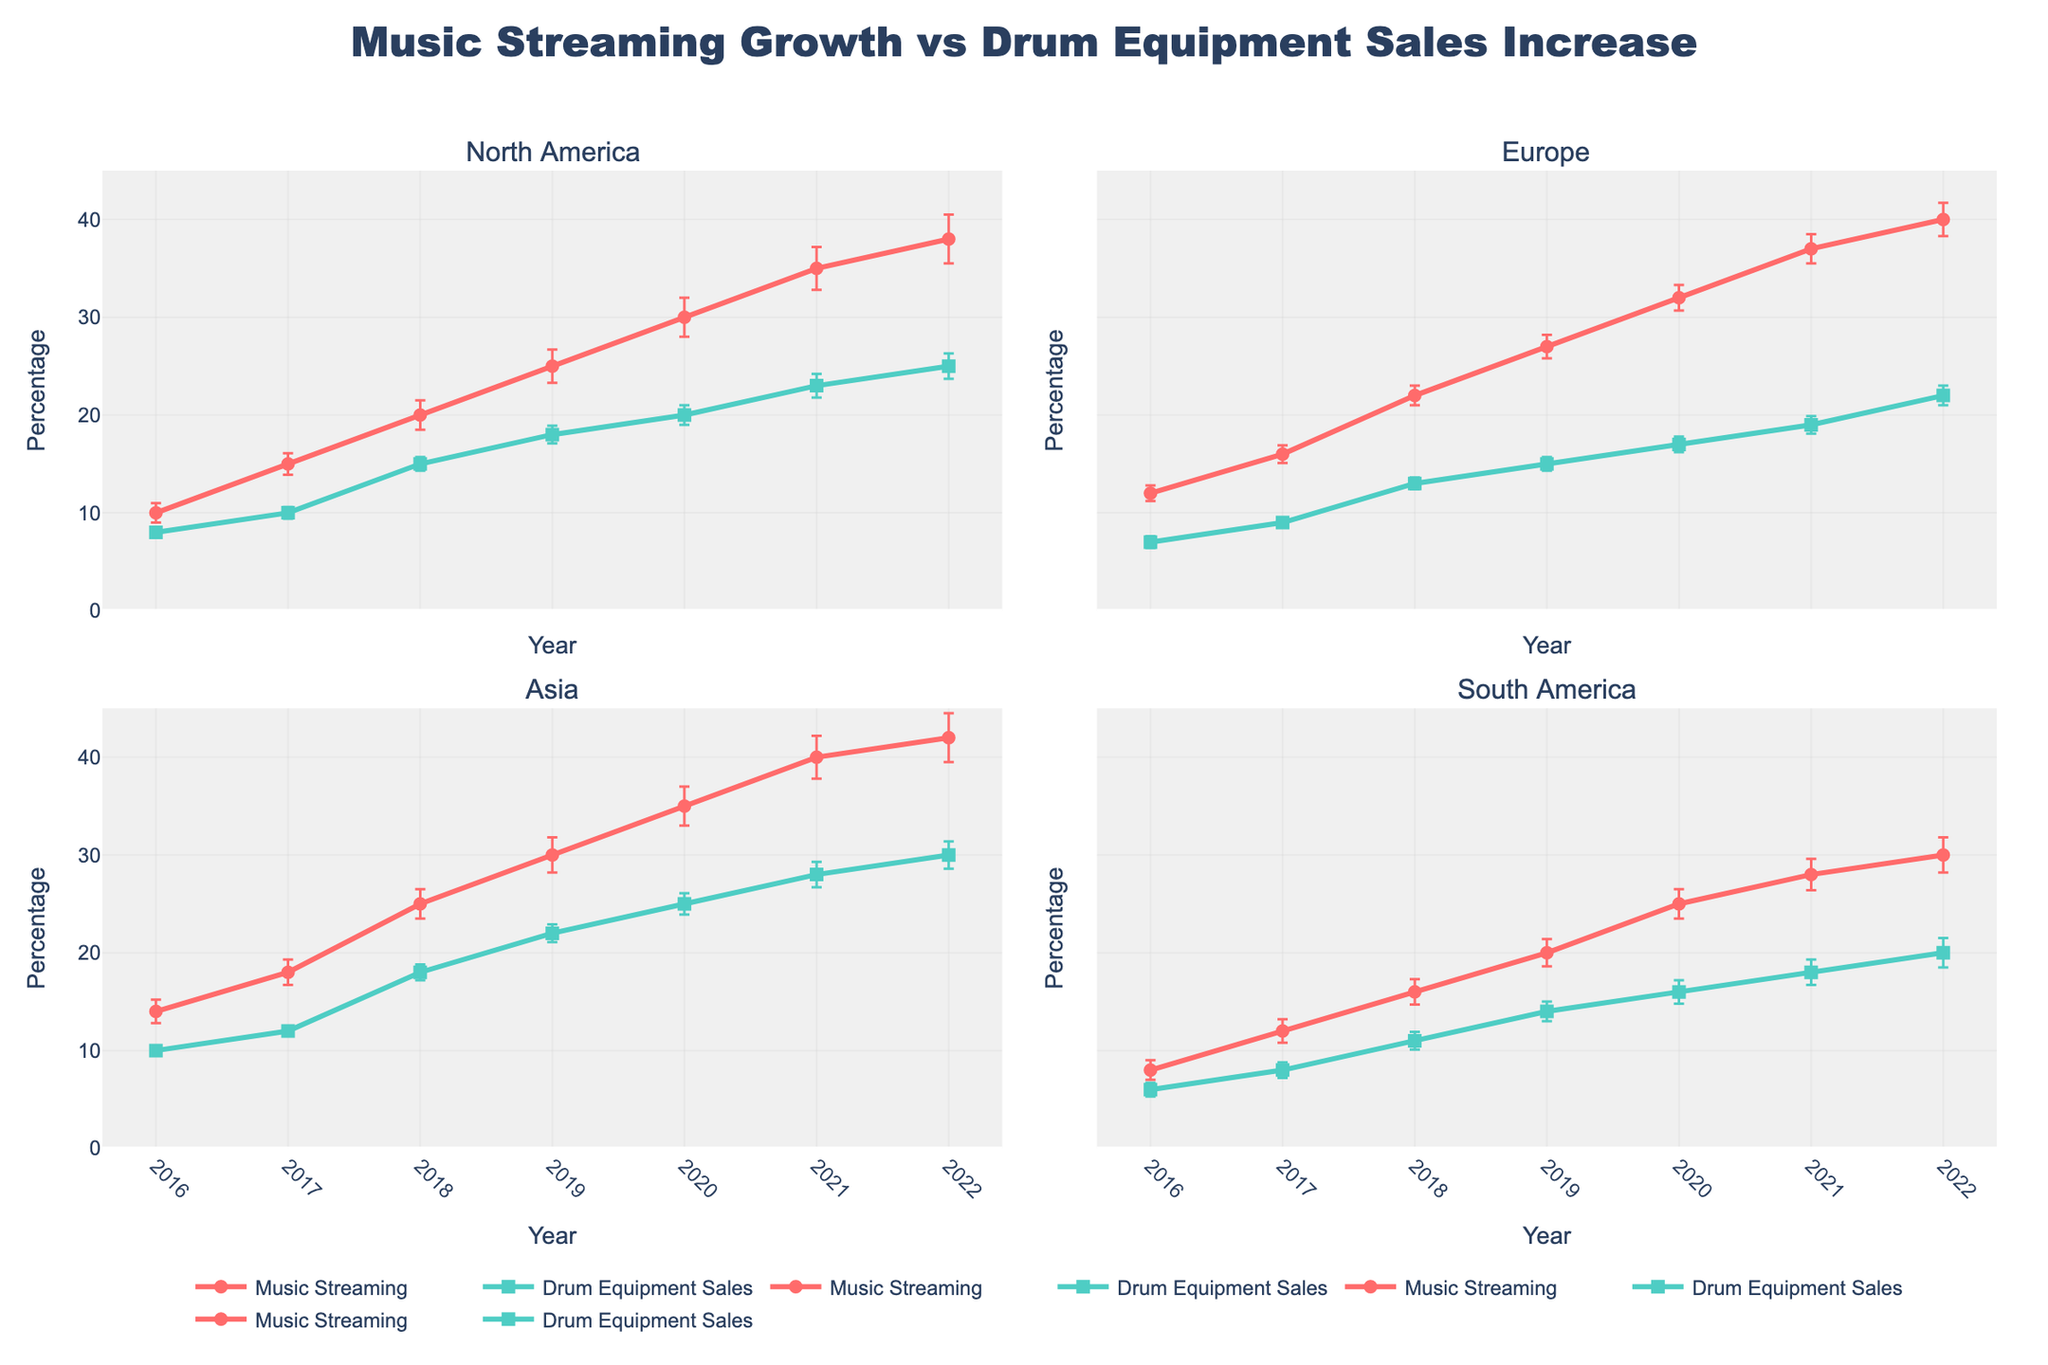How does the growth of music streaming subscribers in North America change from 2016 to 2022? In the plot for North America, look at the trend line for 'Music Streaming Subscribers Growth Percentage.' The line steadily increases each year from 2016 to 2022.
Answer: It increases consistently What is the average drum equipment sales increase percentage in Europe from 2016 to 2022? To compute the average, sum the drum equipment sales increases for Europe from 2016 to 2022: 7 + 9 + 13 + 15 + 17 + 19 + 22. Then divide by the number of years, which is 7.
Answer: (7 + 9 + 13 + 15 + 17 + 19 + 22) / 7 = 14.57 Between Asia and South America, which region has the highest percentage increase in drum equipment sales in 2020? Look at the plots for Asia and South America in 2020. Compare the 'Drum Equipment Sales Increase Percentage' values. Asia has 25%, and South America has 16%.
Answer: Asia Are the error bars for music streaming subscribers growth in 2021 larger for North America or Europe? Compare the error bars in the 2021 data points for music streaming subscribers growth in North America and Europe. North America's error bar is larger.
Answer: North America Did any region experience a decline in drum equipment sales increase from one year to another between 2016 and 2022? Check the plots for each region to see if any 'Drum Equipment Sales Increase Percentage' lines dip below the previous year. None of the regions experienced a decline.
Answer: No How did the drum equipment sales increase in Asia compare to the average increase across all regions in 2019? First, find Asia's drum equipment sales increase in 2019, which is 22%. Next, calculate the average increase across all regions in 2019: (18 + 15 + 22 + 14) / 4. Compare Asia's value to this average.
Answer: Asia's increase (22%) is higher than the average (17.25%) Which region had the smallest error bars for drum equipment sales increase in 2016? Compare the error bars for drum equipment sales increase among all regions in 2016. Europe has the smallest error bars.
Answer: Europe 